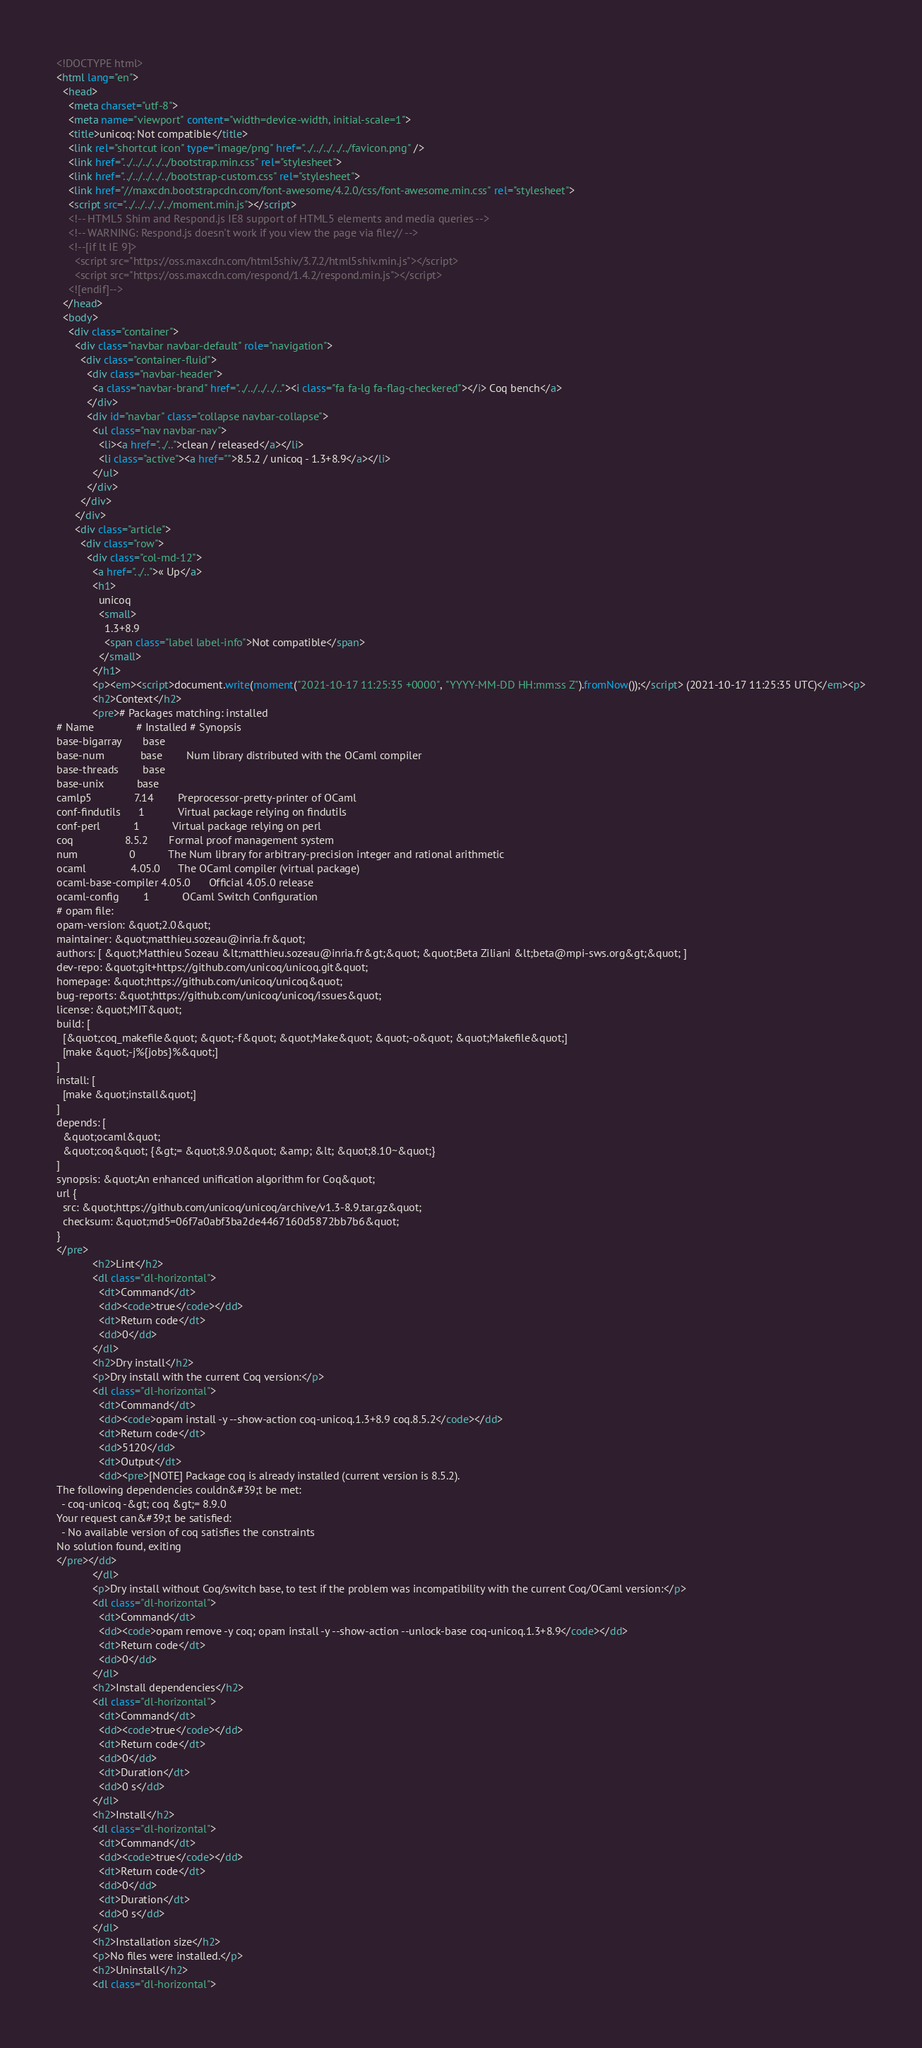<code> <loc_0><loc_0><loc_500><loc_500><_HTML_><!DOCTYPE html>
<html lang="en">
  <head>
    <meta charset="utf-8">
    <meta name="viewport" content="width=device-width, initial-scale=1">
    <title>unicoq: Not compatible</title>
    <link rel="shortcut icon" type="image/png" href="../../../../../favicon.png" />
    <link href="../../../../../bootstrap.min.css" rel="stylesheet">
    <link href="../../../../../bootstrap-custom.css" rel="stylesheet">
    <link href="//maxcdn.bootstrapcdn.com/font-awesome/4.2.0/css/font-awesome.min.css" rel="stylesheet">
    <script src="../../../../../moment.min.js"></script>
    <!-- HTML5 Shim and Respond.js IE8 support of HTML5 elements and media queries -->
    <!-- WARNING: Respond.js doesn't work if you view the page via file:// -->
    <!--[if lt IE 9]>
      <script src="https://oss.maxcdn.com/html5shiv/3.7.2/html5shiv.min.js"></script>
      <script src="https://oss.maxcdn.com/respond/1.4.2/respond.min.js"></script>
    <![endif]-->
  </head>
  <body>
    <div class="container">
      <div class="navbar navbar-default" role="navigation">
        <div class="container-fluid">
          <div class="navbar-header">
            <a class="navbar-brand" href="../../../../.."><i class="fa fa-lg fa-flag-checkered"></i> Coq bench</a>
          </div>
          <div id="navbar" class="collapse navbar-collapse">
            <ul class="nav navbar-nav">
              <li><a href="../..">clean / released</a></li>
              <li class="active"><a href="">8.5.2 / unicoq - 1.3+8.9</a></li>
            </ul>
          </div>
        </div>
      </div>
      <div class="article">
        <div class="row">
          <div class="col-md-12">
            <a href="../..">« Up</a>
            <h1>
              unicoq
              <small>
                1.3+8.9
                <span class="label label-info">Not compatible</span>
              </small>
            </h1>
            <p><em><script>document.write(moment("2021-10-17 11:25:35 +0000", "YYYY-MM-DD HH:mm:ss Z").fromNow());</script> (2021-10-17 11:25:35 UTC)</em><p>
            <h2>Context</h2>
            <pre># Packages matching: installed
# Name              # Installed # Synopsis
base-bigarray       base
base-num            base        Num library distributed with the OCaml compiler
base-threads        base
base-unix           base
camlp5              7.14        Preprocessor-pretty-printer of OCaml
conf-findutils      1           Virtual package relying on findutils
conf-perl           1           Virtual package relying on perl
coq                 8.5.2       Formal proof management system
num                 0           The Num library for arbitrary-precision integer and rational arithmetic
ocaml               4.05.0      The OCaml compiler (virtual package)
ocaml-base-compiler 4.05.0      Official 4.05.0 release
ocaml-config        1           OCaml Switch Configuration
# opam file:
opam-version: &quot;2.0&quot;
maintainer: &quot;matthieu.sozeau@inria.fr&quot;
authors: [ &quot;Matthieu Sozeau &lt;matthieu.sozeau@inria.fr&gt;&quot; &quot;Beta Ziliani &lt;beta@mpi-sws.org&gt;&quot; ]
dev-repo: &quot;git+https://github.com/unicoq/unicoq.git&quot;
homepage: &quot;https://github.com/unicoq/unicoq&quot;
bug-reports: &quot;https://github.com/unicoq/unicoq/issues&quot;
license: &quot;MIT&quot;
build: [
  [&quot;coq_makefile&quot; &quot;-f&quot; &quot;Make&quot; &quot;-o&quot; &quot;Makefile&quot;]
  [make &quot;-j%{jobs}%&quot;]
]
install: [
  [make &quot;install&quot;]
]
depends: [
  &quot;ocaml&quot;
  &quot;coq&quot; {&gt;= &quot;8.9.0&quot; &amp; &lt; &quot;8.10~&quot;}
]
synopsis: &quot;An enhanced unification algorithm for Coq&quot;
url {
  src: &quot;https://github.com/unicoq/unicoq/archive/v1.3-8.9.tar.gz&quot;
  checksum: &quot;md5=06f7a0abf3ba2de4467160d5872bb7b6&quot;
}
</pre>
            <h2>Lint</h2>
            <dl class="dl-horizontal">
              <dt>Command</dt>
              <dd><code>true</code></dd>
              <dt>Return code</dt>
              <dd>0</dd>
            </dl>
            <h2>Dry install</h2>
            <p>Dry install with the current Coq version:</p>
            <dl class="dl-horizontal">
              <dt>Command</dt>
              <dd><code>opam install -y --show-action coq-unicoq.1.3+8.9 coq.8.5.2</code></dd>
              <dt>Return code</dt>
              <dd>5120</dd>
              <dt>Output</dt>
              <dd><pre>[NOTE] Package coq is already installed (current version is 8.5.2).
The following dependencies couldn&#39;t be met:
  - coq-unicoq -&gt; coq &gt;= 8.9.0
Your request can&#39;t be satisfied:
  - No available version of coq satisfies the constraints
No solution found, exiting
</pre></dd>
            </dl>
            <p>Dry install without Coq/switch base, to test if the problem was incompatibility with the current Coq/OCaml version:</p>
            <dl class="dl-horizontal">
              <dt>Command</dt>
              <dd><code>opam remove -y coq; opam install -y --show-action --unlock-base coq-unicoq.1.3+8.9</code></dd>
              <dt>Return code</dt>
              <dd>0</dd>
            </dl>
            <h2>Install dependencies</h2>
            <dl class="dl-horizontal">
              <dt>Command</dt>
              <dd><code>true</code></dd>
              <dt>Return code</dt>
              <dd>0</dd>
              <dt>Duration</dt>
              <dd>0 s</dd>
            </dl>
            <h2>Install</h2>
            <dl class="dl-horizontal">
              <dt>Command</dt>
              <dd><code>true</code></dd>
              <dt>Return code</dt>
              <dd>0</dd>
              <dt>Duration</dt>
              <dd>0 s</dd>
            </dl>
            <h2>Installation size</h2>
            <p>No files were installed.</p>
            <h2>Uninstall</h2>
            <dl class="dl-horizontal"></code> 